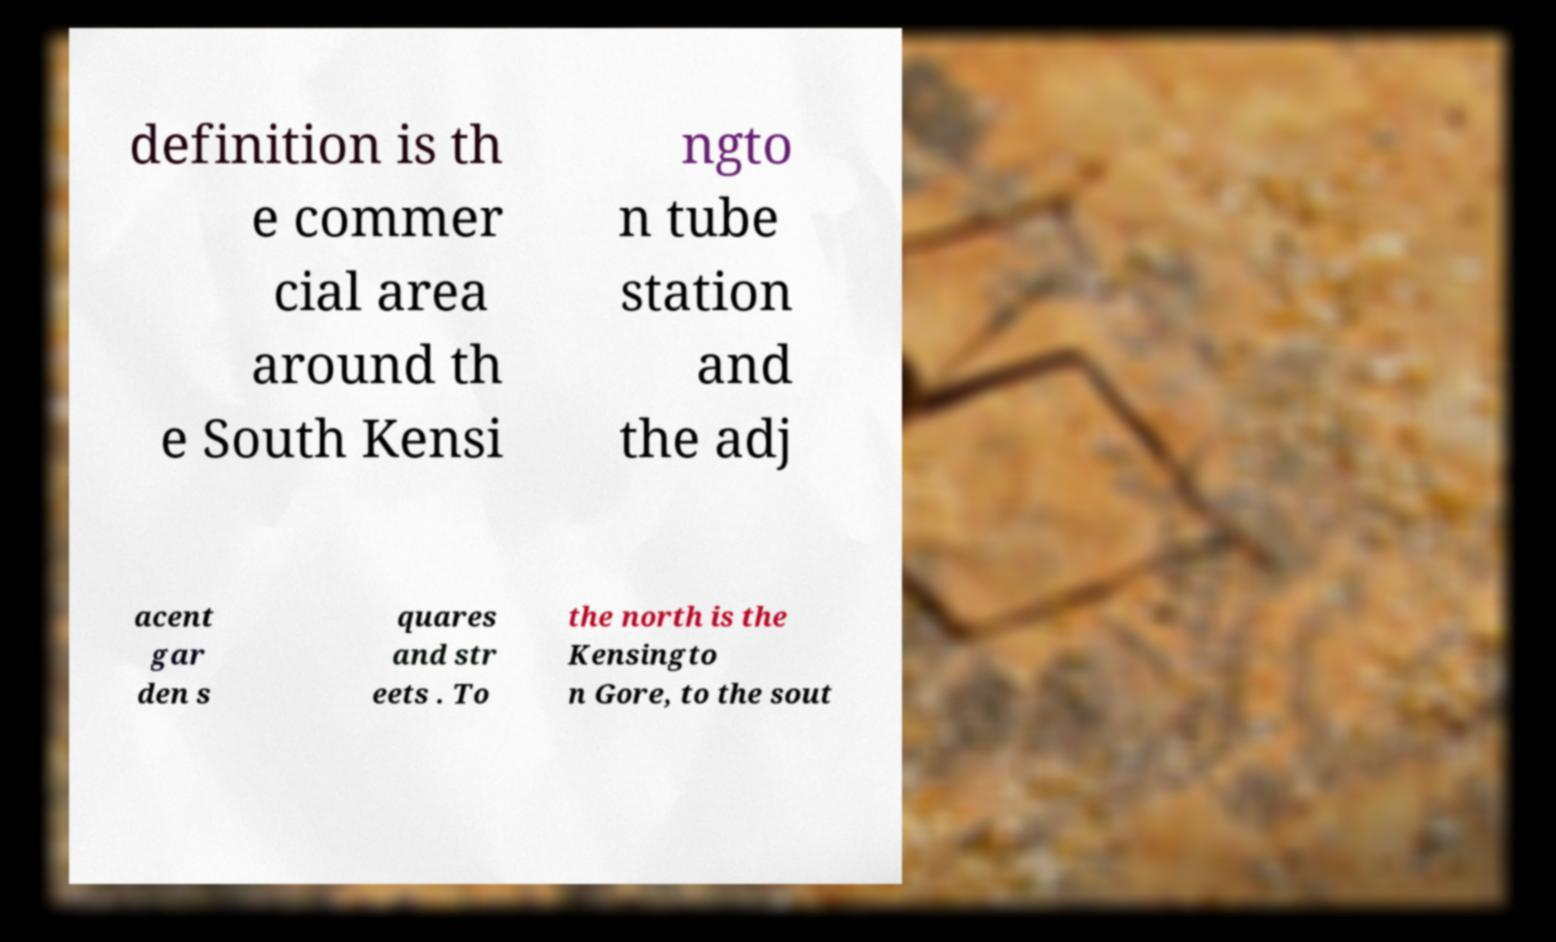Please identify and transcribe the text found in this image. definition is th e commer cial area around th e South Kensi ngto n tube station and the adj acent gar den s quares and str eets . To the north is the Kensingto n Gore, to the sout 